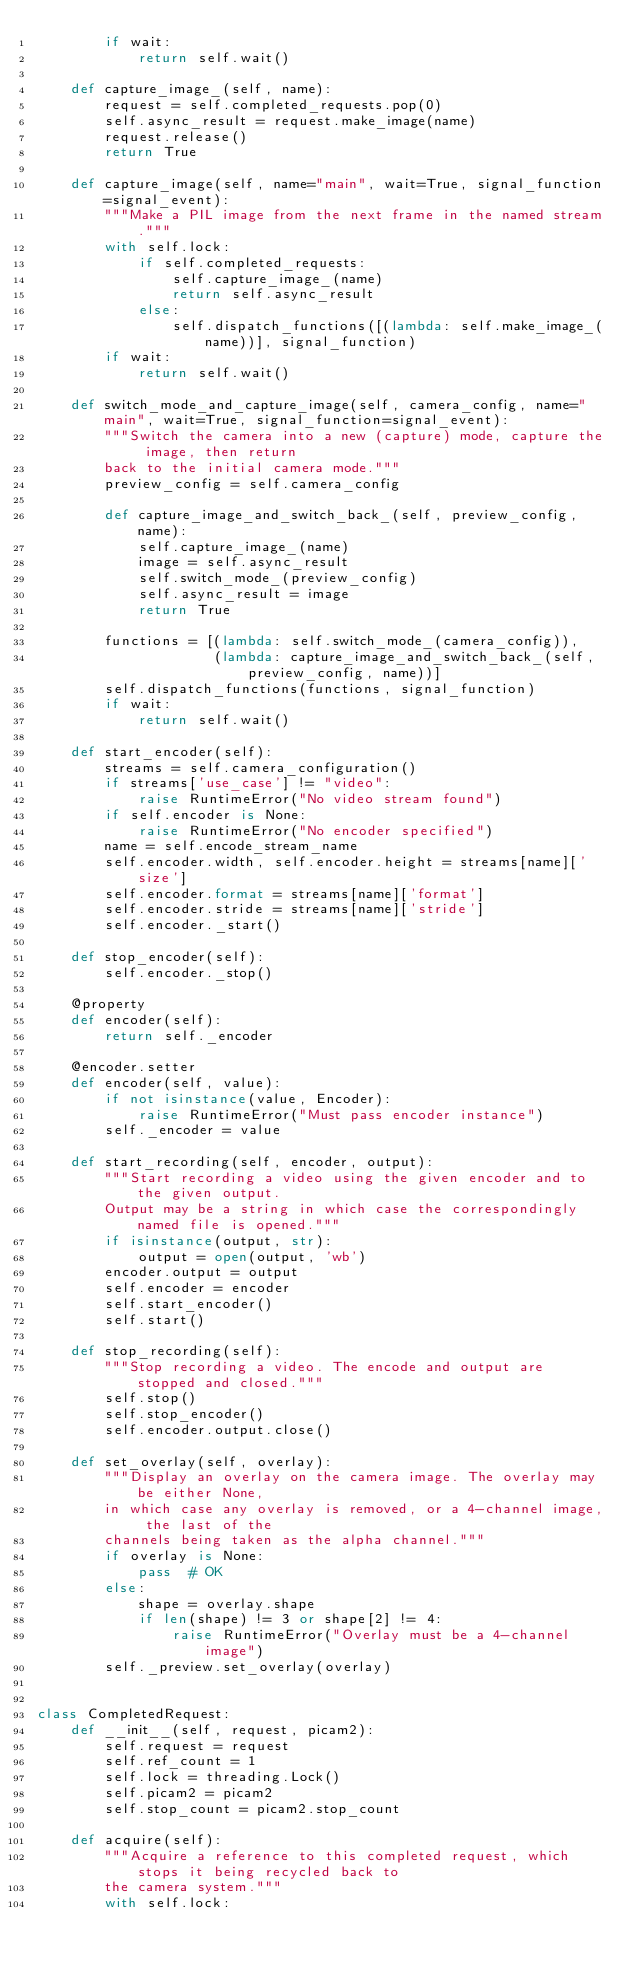<code> <loc_0><loc_0><loc_500><loc_500><_Python_>        if wait:
            return self.wait()

    def capture_image_(self, name):
        request = self.completed_requests.pop(0)
        self.async_result = request.make_image(name)
        request.release()
        return True

    def capture_image(self, name="main", wait=True, signal_function=signal_event):
        """Make a PIL image from the next frame in the named stream."""
        with self.lock:
            if self.completed_requests:
                self.capture_image_(name)
                return self.async_result
            else:
                self.dispatch_functions([(lambda: self.make_image_(name))], signal_function)
        if wait:
            return self.wait()

    def switch_mode_and_capture_image(self, camera_config, name="main", wait=True, signal_function=signal_event):
        """Switch the camera into a new (capture) mode, capture the image, then return
        back to the initial camera mode."""
        preview_config = self.camera_config

        def capture_image_and_switch_back_(self, preview_config, name):
            self.capture_image_(name)
            image = self.async_result
            self.switch_mode_(preview_config)
            self.async_result = image
            return True

        functions = [(lambda: self.switch_mode_(camera_config)),
                     (lambda: capture_image_and_switch_back_(self, preview_config, name))]
        self.dispatch_functions(functions, signal_function)
        if wait:
            return self.wait()

    def start_encoder(self):
        streams = self.camera_configuration()
        if streams['use_case'] != "video":
            raise RuntimeError("No video stream found")
        if self.encoder is None:
            raise RuntimeError("No encoder specified")
        name = self.encode_stream_name
        self.encoder.width, self.encoder.height = streams[name]['size']
        self.encoder.format = streams[name]['format']
        self.encoder.stride = streams[name]['stride']
        self.encoder._start()

    def stop_encoder(self):
        self.encoder._stop()

    @property
    def encoder(self):
        return self._encoder

    @encoder.setter
    def encoder(self, value):
        if not isinstance(value, Encoder):
            raise RuntimeError("Must pass encoder instance")
        self._encoder = value

    def start_recording(self, encoder, output):
        """Start recording a video using the given encoder and to the given output.
        Output may be a string in which case the correspondingly named file is opened."""
        if isinstance(output, str):
            output = open(output, 'wb')
        encoder.output = output
        self.encoder = encoder
        self.start_encoder()
        self.start()

    def stop_recording(self):
        """Stop recording a video. The encode and output are stopped and closed."""
        self.stop()
        self.stop_encoder()
        self.encoder.output.close()

    def set_overlay(self, overlay):
        """Display an overlay on the camera image. The overlay may be either None,
        in which case any overlay is removed, or a 4-channel image, the last of the
        channels being taken as the alpha channel."""
        if overlay is None:
            pass  # OK
        else:
            shape = overlay.shape
            if len(shape) != 3 or shape[2] != 4:
                raise RuntimeError("Overlay must be a 4-channel image")
        self._preview.set_overlay(overlay)


class CompletedRequest:
    def __init__(self, request, picam2):
        self.request = request
        self.ref_count = 1
        self.lock = threading.Lock()
        self.picam2 = picam2
        self.stop_count = picam2.stop_count

    def acquire(self):
        """Acquire a reference to this completed request, which stops it being recycled back to
        the camera system."""
        with self.lock:</code> 